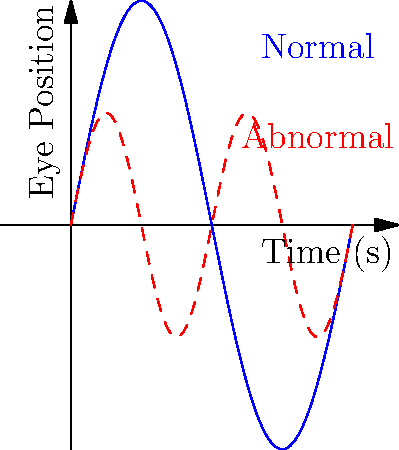The graph shows electronystagmography (ENG) results for two patients during a caloric test. The blue line represents a normal response, while the red dashed line represents an abnormal response. What does the difference in amplitude between the two responses suggest about the patient with the abnormal result? To interpret these ENG results, we need to consider the following steps:

1. Amplitude analysis:
   - The blue line (normal response) has a larger peak-to-peak amplitude.
   - The red dashed line (abnormal response) has a smaller peak-to-peak amplitude.

2. Physiological interpretation:
   - Amplitude in ENG represents the strength of the vestibular response.
   - A larger amplitude indicates a stronger vestibular reaction.
   - A smaller amplitude suggests a weaker vestibular reaction.

3. Clinical significance:
   - The reduced amplitude in the abnormal response (red dashed line) indicates a decreased vestibular function.
   - This could be due to various factors affecting the vestibular system, such as:
     a. Vestibular hypofunction
     b. Vestibular nerve damage
     c. Labyrinthine disorder

4. Quantitative assessment:
   - The abnormal response shows approximately half the amplitude of the normal response.
   - This suggests a significant reduction in vestibular function, potentially by about 50%.

5. Diagnostic implications:
   - The marked reduction in amplitude warrants further investigation.
   - Additional tests may be needed to determine the exact cause and extent of the vestibular dysfunction.

Given these observations, the difference in amplitude suggests a reduced vestibular function in the patient with the abnormal result.
Answer: Reduced vestibular function 